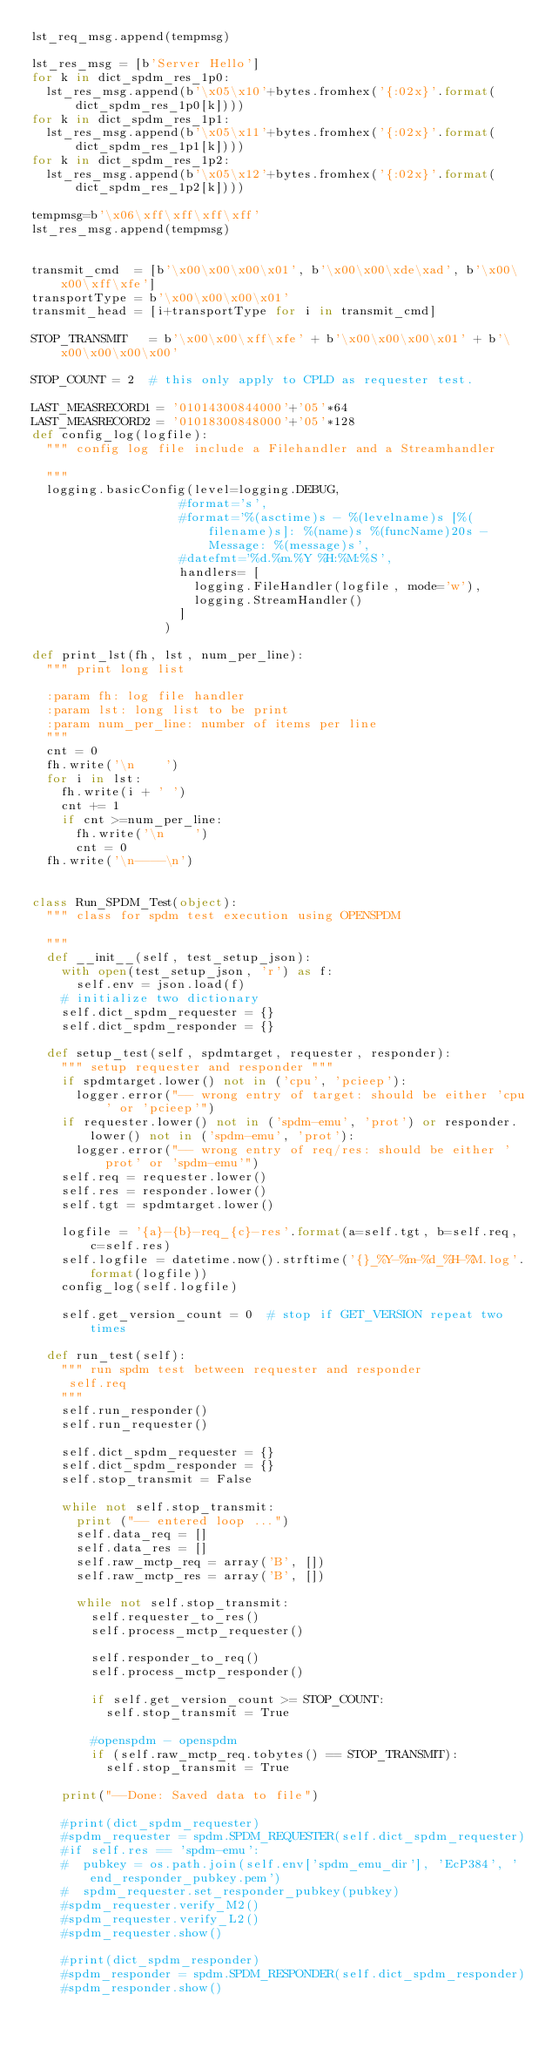Convert code to text. <code><loc_0><loc_0><loc_500><loc_500><_Python_>lst_req_msg.append(tempmsg)

lst_res_msg = [b'Server Hello']
for k in dict_spdm_res_1p0:
  lst_res_msg.append(b'\x05\x10'+bytes.fromhex('{:02x}'.format(dict_spdm_res_1p0[k])))
for k in dict_spdm_res_1p1:
  lst_res_msg.append(b'\x05\x11'+bytes.fromhex('{:02x}'.format(dict_spdm_res_1p1[k])))
for k in dict_spdm_res_1p2:
  lst_res_msg.append(b'\x05\x12'+bytes.fromhex('{:02x}'.format(dict_spdm_res_1p2[k])))

tempmsg=b'\x06\xff\xff\xff\xff'
lst_res_msg.append(tempmsg)


transmit_cmd  = [b'\x00\x00\x00\x01', b'\x00\x00\xde\xad', b'\x00\x00\xff\xfe']
transportType = b'\x00\x00\x00\x01'
transmit_head = [i+transportType for i in transmit_cmd]

STOP_TRANSMIT   = b'\x00\x00\xff\xfe' + b'\x00\x00\x00\x01' + b'\x00\x00\x00\x00'

STOP_COUNT = 2  # this only apply to CPLD as requester test.

LAST_MEASRECORD1 = '01014300844000'+'05'*64
LAST_MEASRECORD2 = '01018300848000'+'05'*128
def config_log(logfile):
  """ config log file include a Filehandler and a Streamhandler

  """
  logging.basicConfig(level=logging.DEBUG,
                    #format='s',
                    #format='%(asctime)s - %(levelname)s [%(filename)s]: %(name)s %(funcName)20s - Message: %(message)s',
                    #datefmt='%d.%m.%Y %H:%M:%S',
                    handlers= [
                      logging.FileHandler(logfile, mode='w'),
                      logging.StreamHandler()
                    ]
                  )

def print_lst(fh, lst, num_per_line):
  """ print long list

  :param fh: log file handler
  :param lst: long list to be print
  :param num_per_line: number of items per line
  """
  cnt = 0
  fh.write('\n    ')
  for i in lst:
    fh.write(i + ' ')
    cnt += 1
    if cnt >=num_per_line:
      fh.write('\n    ')
      cnt = 0
  fh.write('\n----\n')


class Run_SPDM_Test(object):
  """ class for spdm test execution using OPENSPDM

  """
  def __init__(self, test_setup_json):
    with open(test_setup_json, 'r') as f:
      self.env = json.load(f)
    # initialize two dictionary
    self.dict_spdm_requester = {}
    self.dict_spdm_responder = {}

  def setup_test(self, spdmtarget, requester, responder):
    """ setup requester and responder """
    if spdmtarget.lower() not in ('cpu', 'pcieep'):
      logger.error("-- wrong entry of target: should be either 'cpu' or 'pcieep'")
    if requester.lower() not in ('spdm-emu', 'prot') or responder.lower() not in ('spdm-emu', 'prot'):
      logger.error("-- wrong entry of req/res: should be either 'prot' or 'spdm-emu'")
    self.req = requester.lower()
    self.res = responder.lower()
    self.tgt = spdmtarget.lower()

    logfile = '{a}-{b}-req_{c}-res'.format(a=self.tgt, b=self.req, c=self.res)
    self.logfile = datetime.now().strftime('{}_%Y-%m-%d_%H-%M.log'.format(logfile))
    config_log(self.logfile)

    self.get_version_count = 0  # stop if GET_VERSION repeat two times

  def run_test(self):
    """ run spdm test between requester and responder
     self.req
    """
    self.run_responder()
    self.run_requester()

    self.dict_spdm_requester = {}
    self.dict_spdm_responder = {}
    self.stop_transmit = False

    while not self.stop_transmit:
      print ("-- entered loop ...")
      self.data_req = []
      self.data_res = []
      self.raw_mctp_req = array('B', [])
      self.raw_mctp_res = array('B', [])

      while not self.stop_transmit:
        self.requester_to_res()
        self.process_mctp_requester()

        self.responder_to_req()
        self.process_mctp_responder()

        if self.get_version_count >= STOP_COUNT:
          self.stop_transmit = True

        #openspdm - openspdm
        if (self.raw_mctp_req.tobytes() == STOP_TRANSMIT):
          self.stop_transmit = True

    print("--Done: Saved data to file")

    #print(dict_spdm_requester)
    #spdm_requester = spdm.SPDM_REQUESTER(self.dict_spdm_requester)
    #if self.res == 'spdm-emu':
    #  pubkey = os.path.join(self.env['spdm_emu_dir'], 'EcP384', 'end_responder_pubkey.pem')
    #  spdm_requester.set_responder_pubkey(pubkey)
    #spdm_requester.verify_M2()
    #spdm_requester.verify_L2()
    #spdm_requester.show()

    #print(dict_spdm_responder)
    #spdm_responder = spdm.SPDM_RESPONDER(self.dict_spdm_responder)
    #spdm_responder.show()</code> 